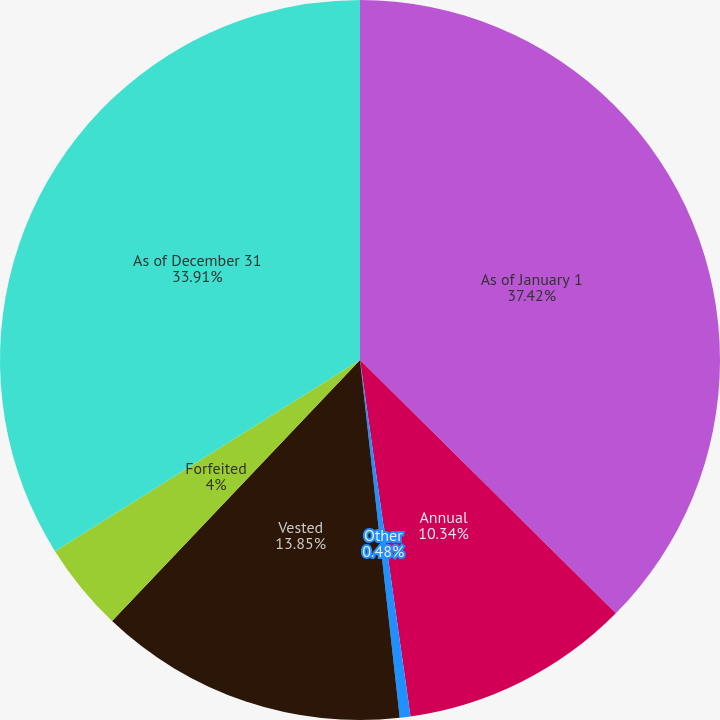<chart> <loc_0><loc_0><loc_500><loc_500><pie_chart><fcel>As of January 1<fcel>Annual<fcel>Other<fcel>Vested<fcel>Forfeited<fcel>As of December 31<nl><fcel>37.42%<fcel>10.34%<fcel>0.48%<fcel>13.85%<fcel>4.0%<fcel>33.91%<nl></chart> 